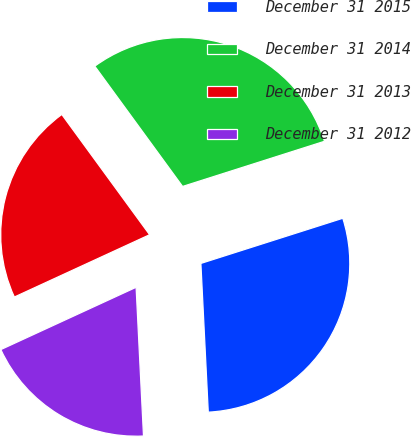<chart> <loc_0><loc_0><loc_500><loc_500><pie_chart><fcel>December 31 2015<fcel>December 31 2014<fcel>December 31 2013<fcel>December 31 2012<nl><fcel>29.11%<fcel>30.13%<fcel>21.83%<fcel>18.92%<nl></chart> 